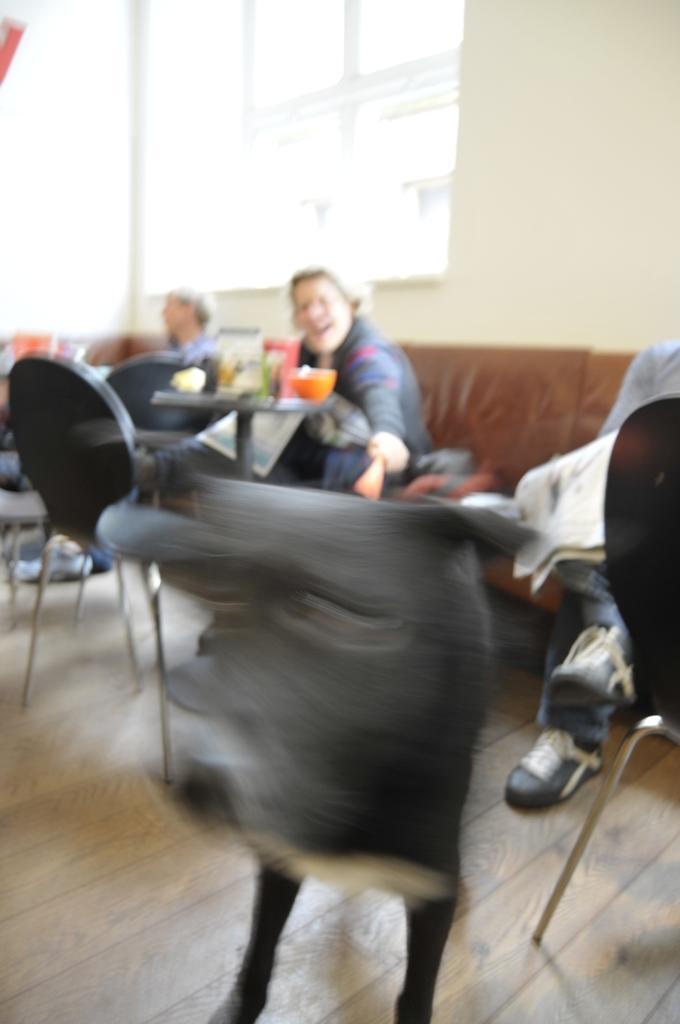Describe this image in one or two sentences. In this picture there is a woman sitting in the chairs in front of a table. In the background there is a window and a wall here. 